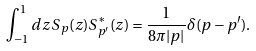<formula> <loc_0><loc_0><loc_500><loc_500>\int _ { - 1 } ^ { 1 } d z \, S _ { p } ( z ) S _ { p ^ { \prime } } ^ { \ast } ( z ) = \frac { 1 } { 8 \pi | p | } \delta ( p - p ^ { \prime } ) .</formula> 